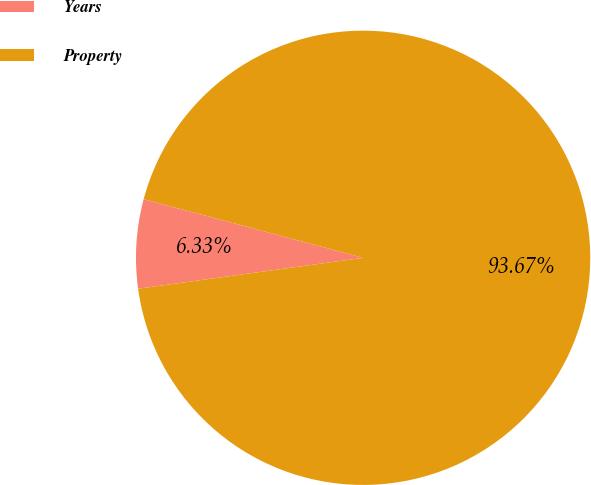<chart> <loc_0><loc_0><loc_500><loc_500><pie_chart><fcel>Years<fcel>Property<nl><fcel>6.33%<fcel>93.67%<nl></chart> 